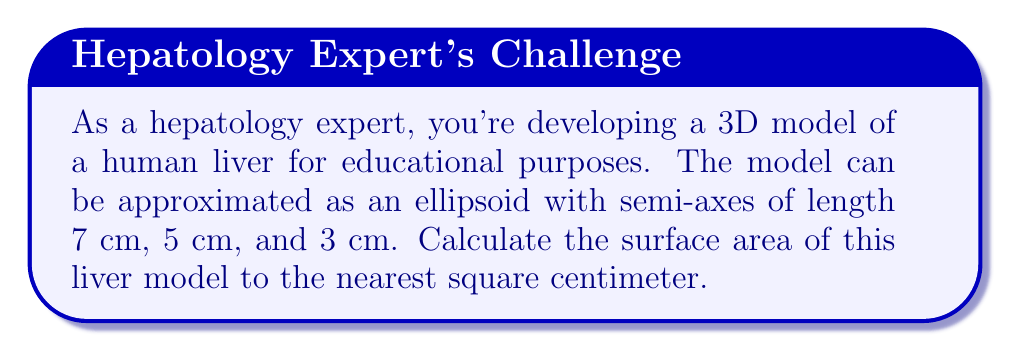Could you help me with this problem? To calculate the surface area of an ellipsoid, we'll use the following steps:

1) The formula for the surface area of an ellipsoid is:

   $$S \approx 4\pi \left(\frac{(ab)^p + (ac)^p + (bc)^p}{3}\right)^{\frac{1}{p}}$$

   where $a$, $b$, and $c$ are the semi-axes lengths, and $p \approx 1.6075$.

2) Given: $a = 7$ cm, $b = 5$ cm, $c = 3$ cm

3) Let's substitute these values into the formula:

   $$S \approx 4\pi \left(\frac{(7 \cdot 5)^{1.6075} + (7 \cdot 3)^{1.6075} + (5 \cdot 3)^{1.6075}}{3}\right)^{\frac{1}{1.6075}}$$

4) Calculate the terms inside the parentheses:
   $(7 \cdot 5)^{1.6075} \approx 268.95$
   $(7 \cdot 3)^{1.6075} \approx 131.76$
   $(5 \cdot 3)^{1.6075} \approx 80.38$

5) Sum these terms and divide by 3:
   $$\frac{268.95 + 131.76 + 80.38}{3} \approx 160.36$$

6) Take this to the power of $\frac{1}{1.6075}$:
   $160.36^{\frac{1}{1.6075}} \approx 8.76$

7) Multiply by $4\pi$:
   $4\pi \cdot 8.76 \approx 110.02$

8) Rounding to the nearest square centimeter:
   $S \approx 110$ cm²
Answer: 110 cm² 